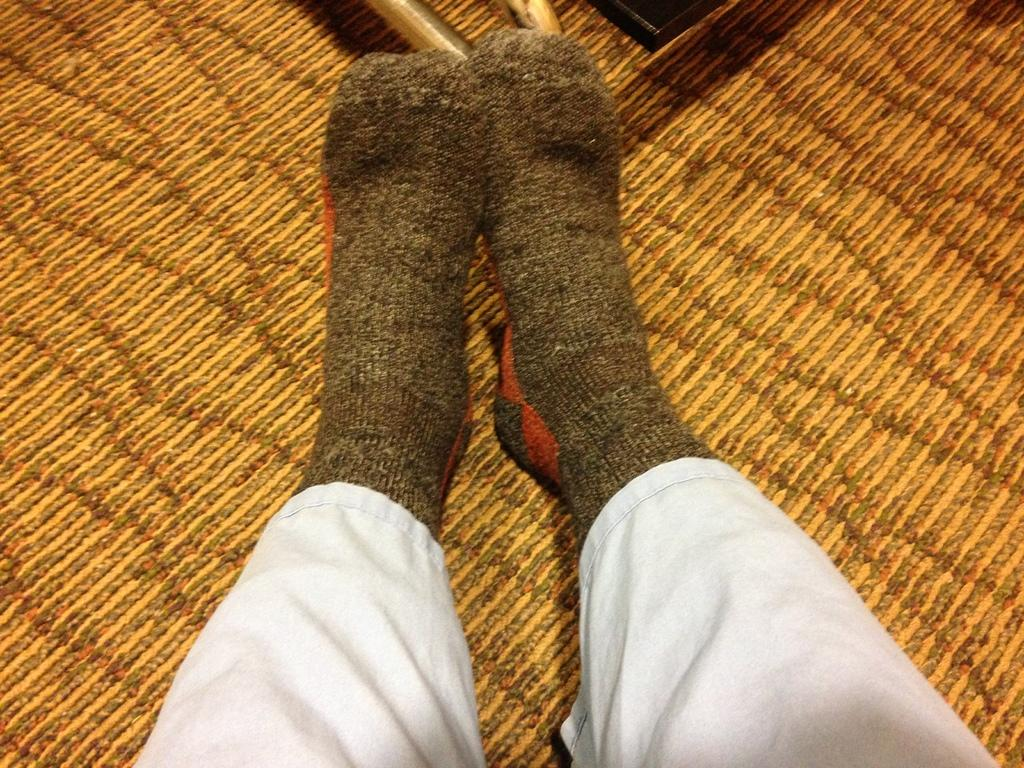What part of a person's body is visible in the image? There is a person's leg visible in the image. What is the person's leg wearing? The leg is wearing socks. What color are the person's trousers? The person is wearing white-colored trousers. What material is the object at the top of the image made of? The object at the top of the image is made of wood. What type of surface can be seen in the background of the image? There is a wooden surface in the background of the image. What advice does the person give about stitching in the image? There is no indication in the image that the person is giving advice about stitching or any other topic. 